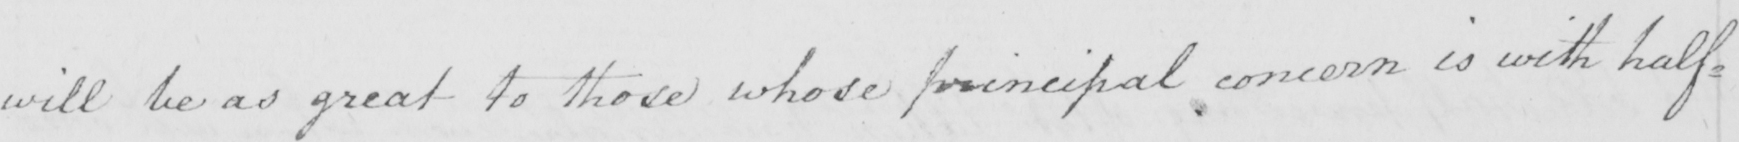What text is written in this handwritten line? will be as great to those whose principal concern is with half= 